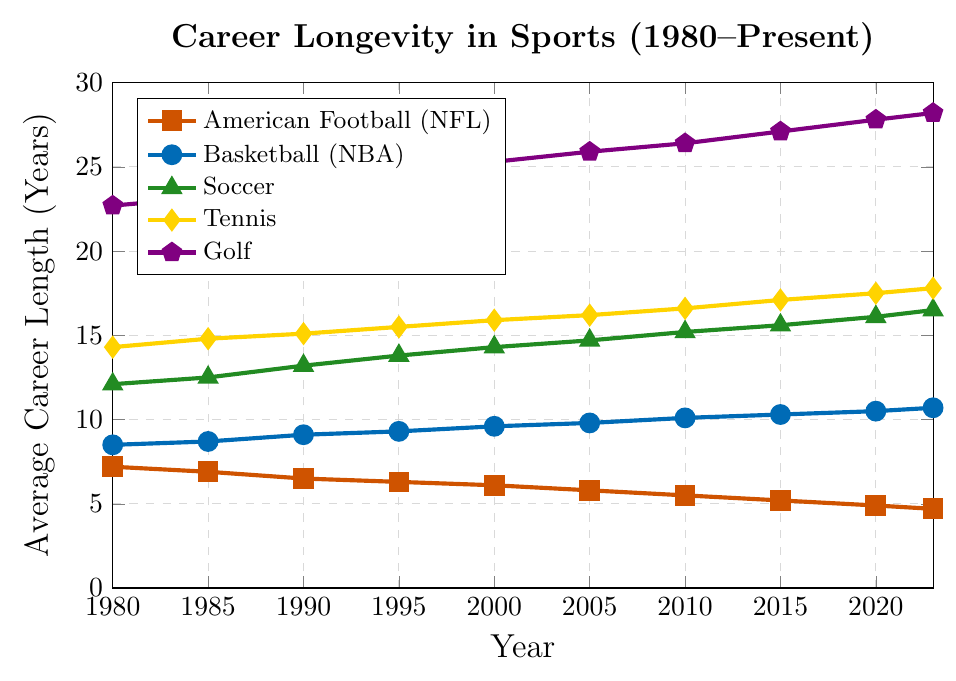What sport had the shortest average career length in 1980? Looking at the data for 1980, American Football (NFL) had the shortest average career length, which was 7.2 years.
Answer: American Football (NFL) Which sport shows a decreasing trend in average career length from 1980 to present? Examining the plot, American Football (NFL) is the sport that shows a clear decreasing trend in average career length from 7.2 years in 1980 to 4.7 years at present.
Answer: American Football (NFL) How has the average career length in Tennis changed from 1980 to present? According to the plot, the average career length in Tennis has gradually increased from 14.3 years in 1980 to 17.8 years at present.
Answer: It increased By how many years has the average career length in Soccer increased from 1980 to present? The data shows the average career length in Soccer was 12.1 years in 1980 and has increased to 16.5 years at present. Therefore, the increase is 16.5 - 12.1 = 4.4 years.
Answer: 4.4 years Which two sports had the closest average career lengths in 2000, and what were their values? According to the plot, Basketball (NBA) and Soccer had the closest average career lengths in 2000, with values of 9.6 and 14.3 years, respectively.
Answer: Basketball (NBA) and Soccer What is the difference in the average career length between Golf and American Football (NFL) in 2020? The plot shows that in 2020, the average career length for Golf was 27.8 years, and for American Football (NFL) it was 4.9 years. The difference is 27.8 - 4.9 = 22.9 years.
Answer: 22.9 years Which sport had the highest increase in average career length from 1980 to present? By comparing the initial and present values in the plot, Golf had the highest increase in average career length, from 22.7 years to 28.2 years.
Answer: Golf What is the average career length across all sports in 1990? Adding the career lengths in 1990: 6.5 (NFL) + 9.1 (NBA) + 13.2 (Soccer) + 15.1 (Tennis) + 24.1 (Golf) = 68 years. The average is 68 / 5 = 13.6 years.
Answer: 13.6 years In which year did Tennis surpass an average career length of 15 years, and has it remained above that length since then? According to the plot, Tennis surpassed an average career length of 15 years in 1990 and has remained above that length since then.
Answer: 1990, yes 